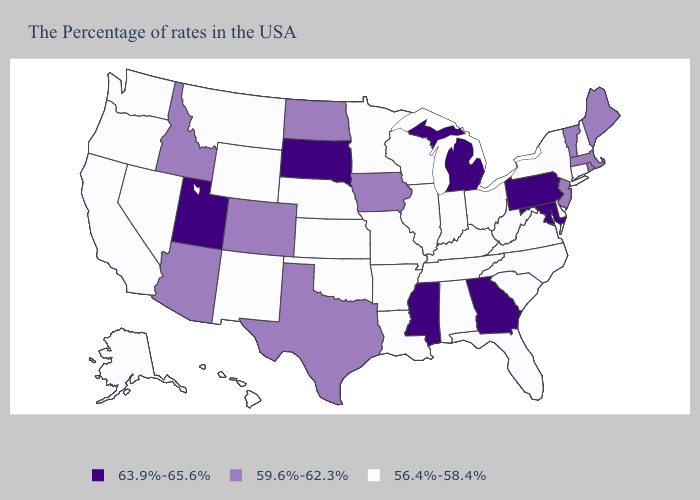What is the value of Louisiana?
Quick response, please. 56.4%-58.4%. Does Iowa have the lowest value in the USA?
Keep it brief. No. Does the map have missing data?
Be succinct. No. Does the map have missing data?
Concise answer only. No. What is the lowest value in the USA?
Give a very brief answer. 56.4%-58.4%. What is the highest value in the USA?
Keep it brief. 63.9%-65.6%. Which states hav the highest value in the Northeast?
Concise answer only. Pennsylvania. What is the value of Louisiana?
Give a very brief answer. 56.4%-58.4%. Among the states that border New Jersey , which have the lowest value?
Give a very brief answer. New York, Delaware. Which states have the highest value in the USA?
Quick response, please. Maryland, Pennsylvania, Georgia, Michigan, Mississippi, South Dakota, Utah. Among the states that border Colorado , does Utah have the highest value?
Short answer required. Yes. What is the highest value in states that border Nevada?
Answer briefly. 63.9%-65.6%. How many symbols are there in the legend?
Short answer required. 3. Among the states that border Vermont , which have the lowest value?
Short answer required. New Hampshire, New York. Name the states that have a value in the range 59.6%-62.3%?
Answer briefly. Maine, Massachusetts, Rhode Island, Vermont, New Jersey, Iowa, Texas, North Dakota, Colorado, Arizona, Idaho. 